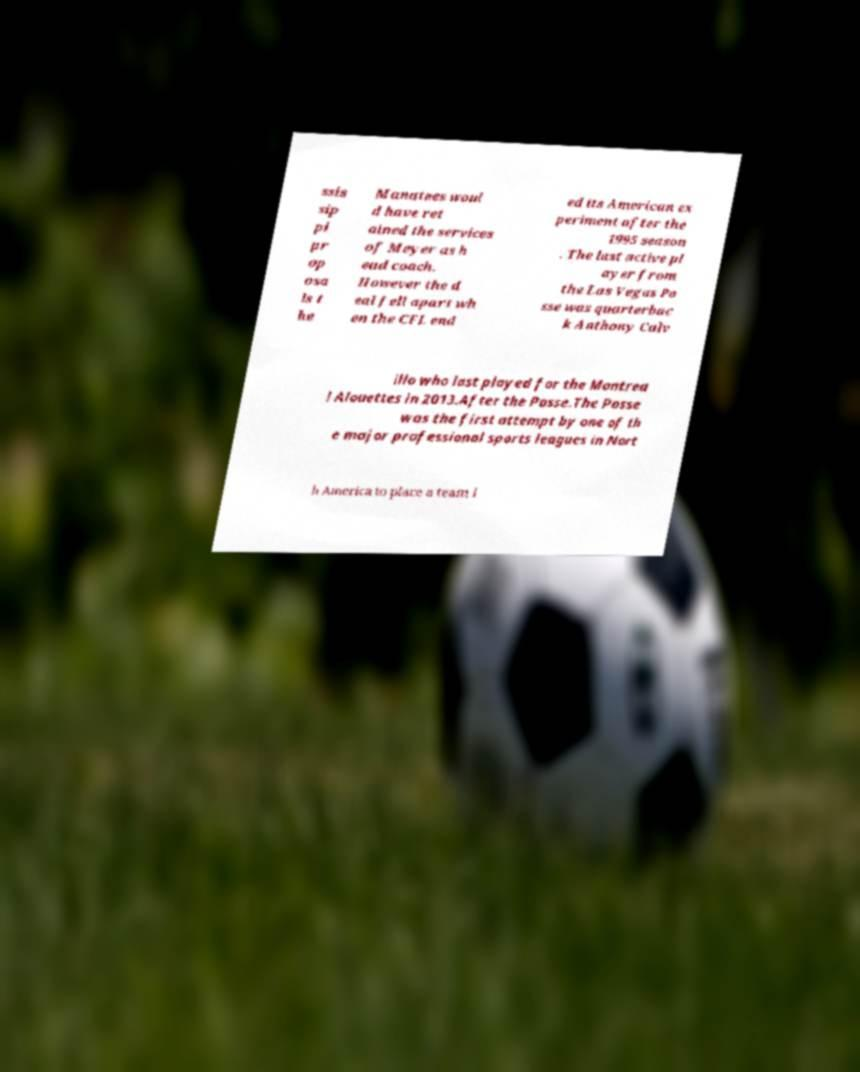Please read and relay the text visible in this image. What does it say? ssis sip pi pr op osa ls t he Manatees woul d have ret ained the services of Meyer as h ead coach. However the d eal fell apart wh en the CFL end ed its American ex periment after the 1995 season . The last active pl ayer from the Las Vegas Po sse was quarterbac k Anthony Calv illo who last played for the Montrea l Alouettes in 2013.After the Posse.The Posse was the first attempt by one of th e major professional sports leagues in Nort h America to place a team i 